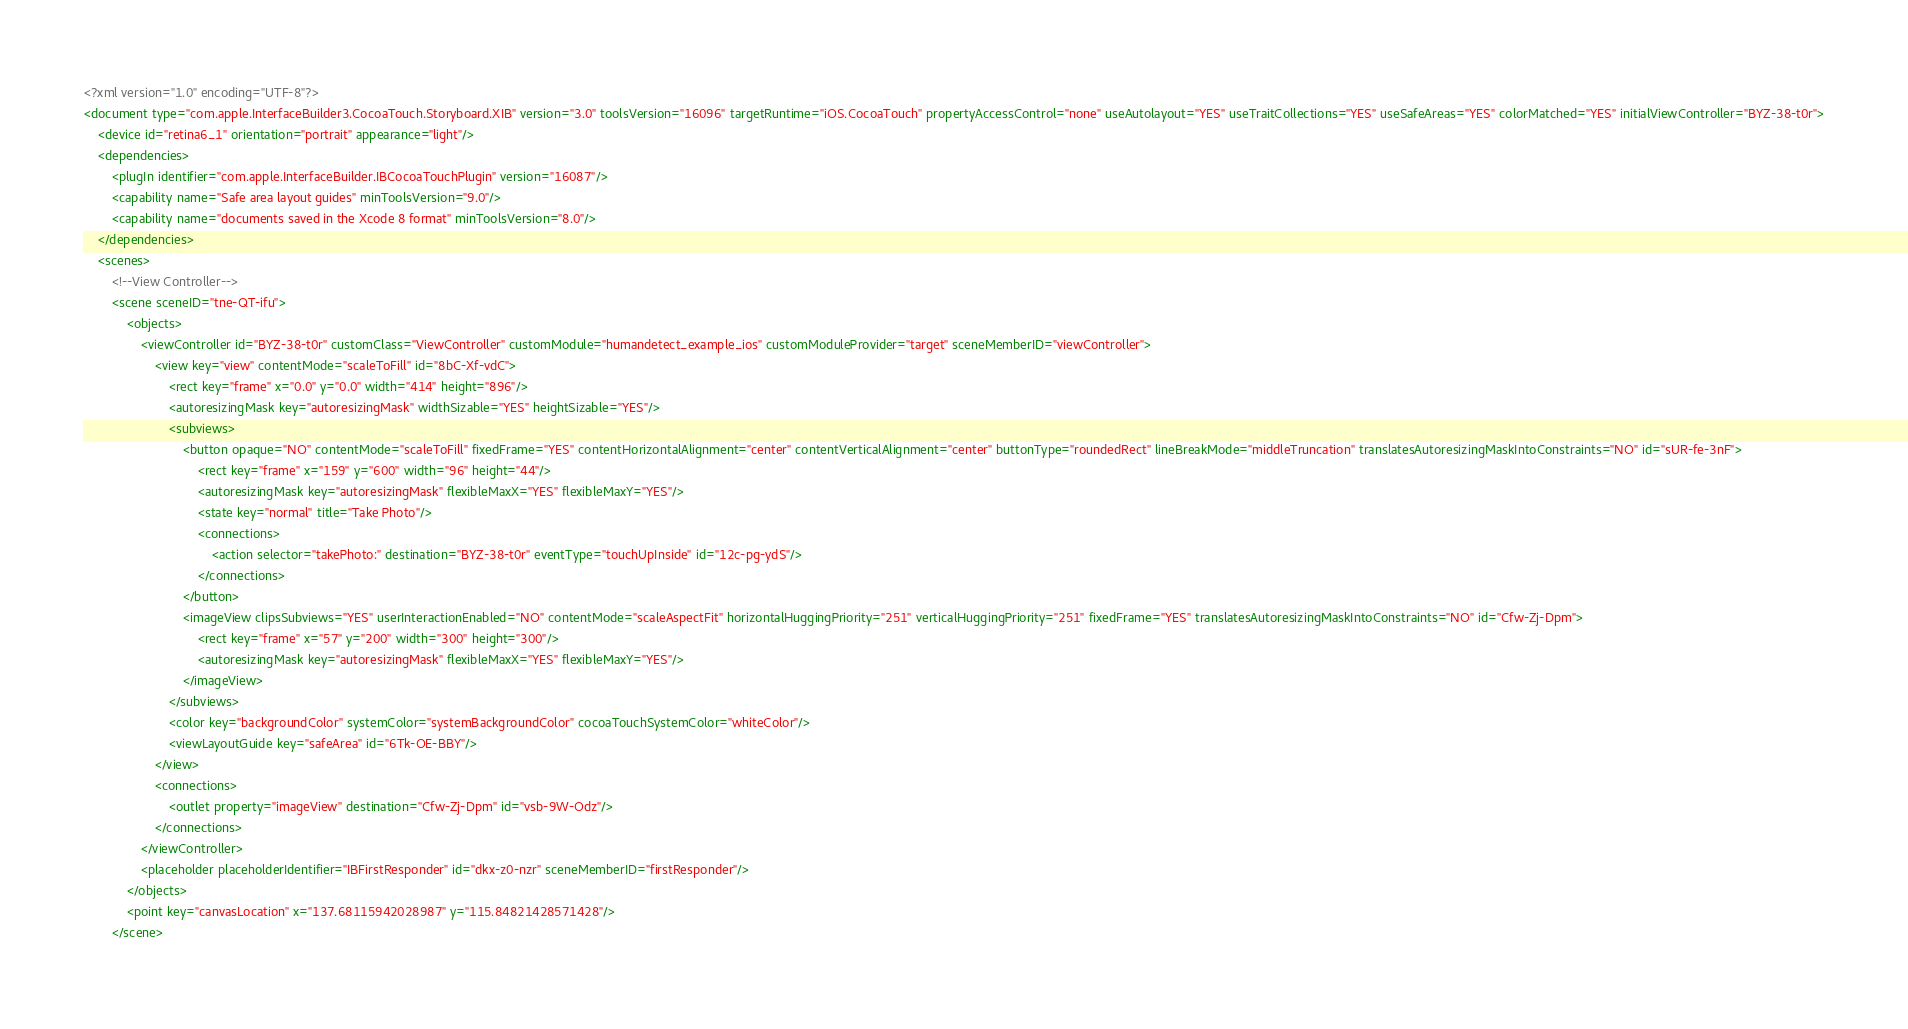<code> <loc_0><loc_0><loc_500><loc_500><_XML_><?xml version="1.0" encoding="UTF-8"?>
<document type="com.apple.InterfaceBuilder3.CocoaTouch.Storyboard.XIB" version="3.0" toolsVersion="16096" targetRuntime="iOS.CocoaTouch" propertyAccessControl="none" useAutolayout="YES" useTraitCollections="YES" useSafeAreas="YES" colorMatched="YES" initialViewController="BYZ-38-t0r">
    <device id="retina6_1" orientation="portrait" appearance="light"/>
    <dependencies>
        <plugIn identifier="com.apple.InterfaceBuilder.IBCocoaTouchPlugin" version="16087"/>
        <capability name="Safe area layout guides" minToolsVersion="9.0"/>
        <capability name="documents saved in the Xcode 8 format" minToolsVersion="8.0"/>
    </dependencies>
    <scenes>
        <!--View Controller-->
        <scene sceneID="tne-QT-ifu">
            <objects>
                <viewController id="BYZ-38-t0r" customClass="ViewController" customModule="humandetect_example_ios" customModuleProvider="target" sceneMemberID="viewController">
                    <view key="view" contentMode="scaleToFill" id="8bC-Xf-vdC">
                        <rect key="frame" x="0.0" y="0.0" width="414" height="896"/>
                        <autoresizingMask key="autoresizingMask" widthSizable="YES" heightSizable="YES"/>
                        <subviews>
                            <button opaque="NO" contentMode="scaleToFill" fixedFrame="YES" contentHorizontalAlignment="center" contentVerticalAlignment="center" buttonType="roundedRect" lineBreakMode="middleTruncation" translatesAutoresizingMaskIntoConstraints="NO" id="sUR-fe-3nF">
                                <rect key="frame" x="159" y="600" width="96" height="44"/>
                                <autoresizingMask key="autoresizingMask" flexibleMaxX="YES" flexibleMaxY="YES"/>
                                <state key="normal" title="Take Photo"/>
                                <connections>
                                    <action selector="takePhoto:" destination="BYZ-38-t0r" eventType="touchUpInside" id="12c-pg-ydS"/>
                                </connections>
                            </button>
                            <imageView clipsSubviews="YES" userInteractionEnabled="NO" contentMode="scaleAspectFit" horizontalHuggingPriority="251" verticalHuggingPriority="251" fixedFrame="YES" translatesAutoresizingMaskIntoConstraints="NO" id="Cfw-Zj-Dpm">
                                <rect key="frame" x="57" y="200" width="300" height="300"/>
                                <autoresizingMask key="autoresizingMask" flexibleMaxX="YES" flexibleMaxY="YES"/>
                            </imageView>
                        </subviews>
                        <color key="backgroundColor" systemColor="systemBackgroundColor" cocoaTouchSystemColor="whiteColor"/>
                        <viewLayoutGuide key="safeArea" id="6Tk-OE-BBY"/>
                    </view>
                    <connections>
                        <outlet property="imageView" destination="Cfw-Zj-Dpm" id="vsb-9W-Odz"/>
                    </connections>
                </viewController>
                <placeholder placeholderIdentifier="IBFirstResponder" id="dkx-z0-nzr" sceneMemberID="firstResponder"/>
            </objects>
            <point key="canvasLocation" x="137.68115942028987" y="115.84821428571428"/>
        </scene></code> 